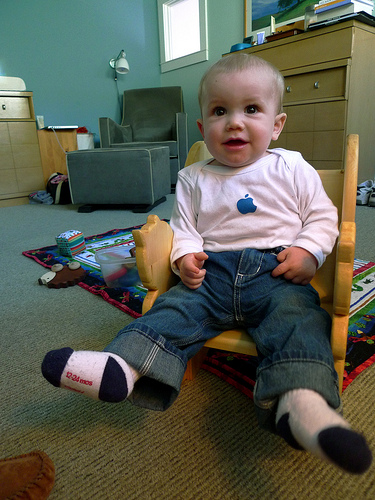<image>
Is there a baby on the carpet? No. The baby is not positioned on the carpet. They may be near each other, but the baby is not supported by or resting on top of the carpet. Where is the boy in relation to the chair? Is it under the chair? No. The boy is not positioned under the chair. The vertical relationship between these objects is different. Is there a sock above the carpet? Yes. The sock is positioned above the carpet in the vertical space, higher up in the scene. 